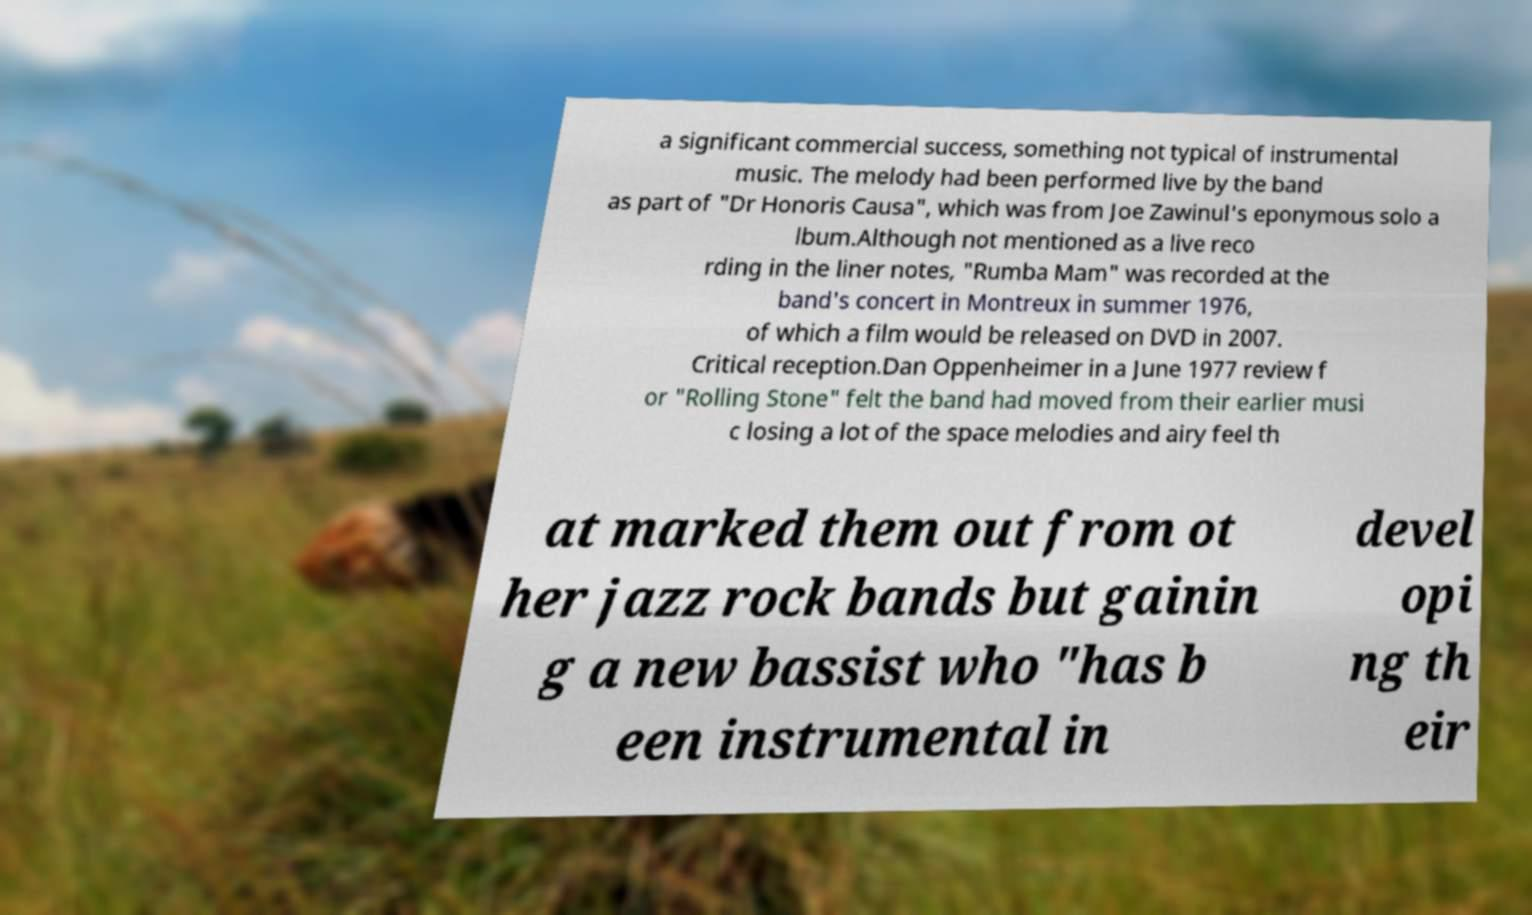I need the written content from this picture converted into text. Can you do that? a significant commercial success, something not typical of instrumental music. The melody had been performed live by the band as part of "Dr Honoris Causa", which was from Joe Zawinul's eponymous solo a lbum.Although not mentioned as a live reco rding in the liner notes, "Rumba Mam" was recorded at the band's concert in Montreux in summer 1976, of which a film would be released on DVD in 2007. Critical reception.Dan Oppenheimer in a June 1977 review f or "Rolling Stone" felt the band had moved from their earlier musi c losing a lot of the space melodies and airy feel th at marked them out from ot her jazz rock bands but gainin g a new bassist who "has b een instrumental in devel opi ng th eir 